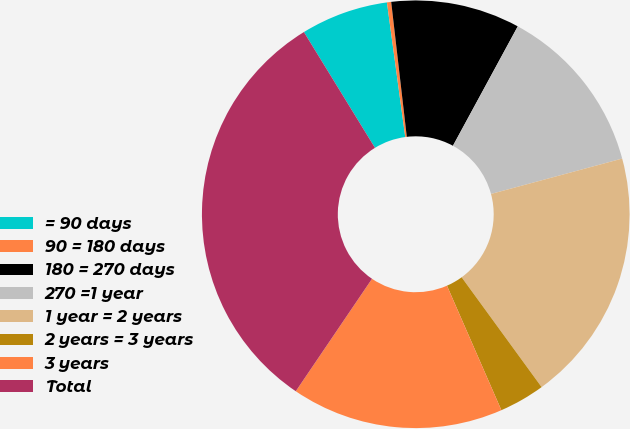Convert chart to OTSL. <chart><loc_0><loc_0><loc_500><loc_500><pie_chart><fcel>= 90 days<fcel>90 = 180 days<fcel>180 = 270 days<fcel>270 =1 year<fcel>1 year = 2 years<fcel>2 years = 3 years<fcel>3 years<fcel>Total<nl><fcel>6.61%<fcel>0.32%<fcel>9.75%<fcel>12.89%<fcel>19.18%<fcel>3.46%<fcel>16.04%<fcel>31.76%<nl></chart> 